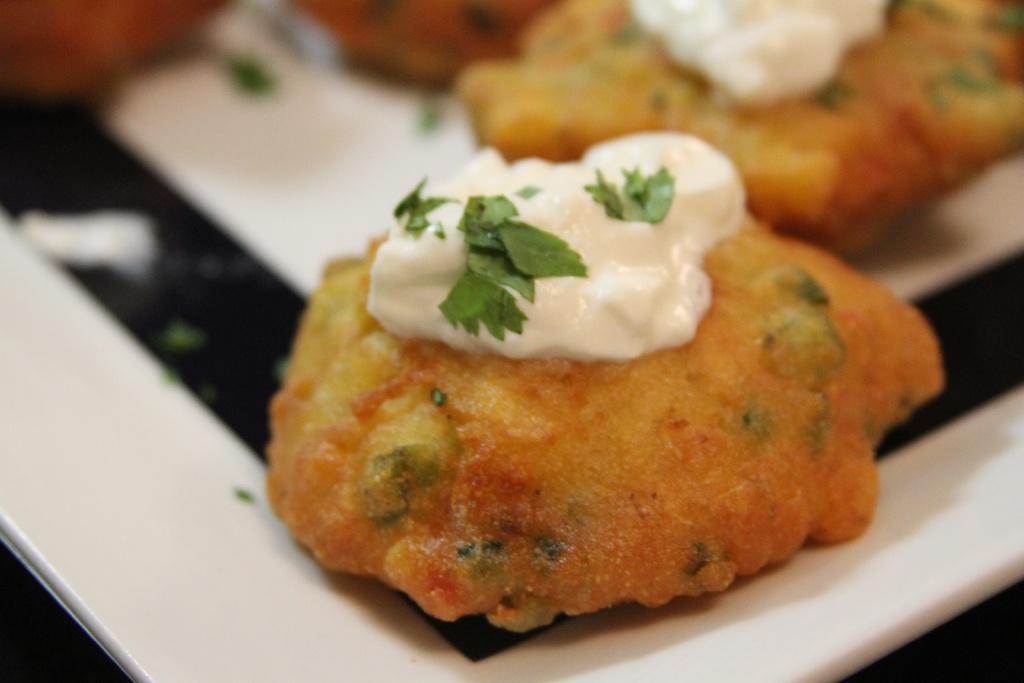In one or two sentences, can you explain what this image depicts? In this picture I can see a food item on the plate. 